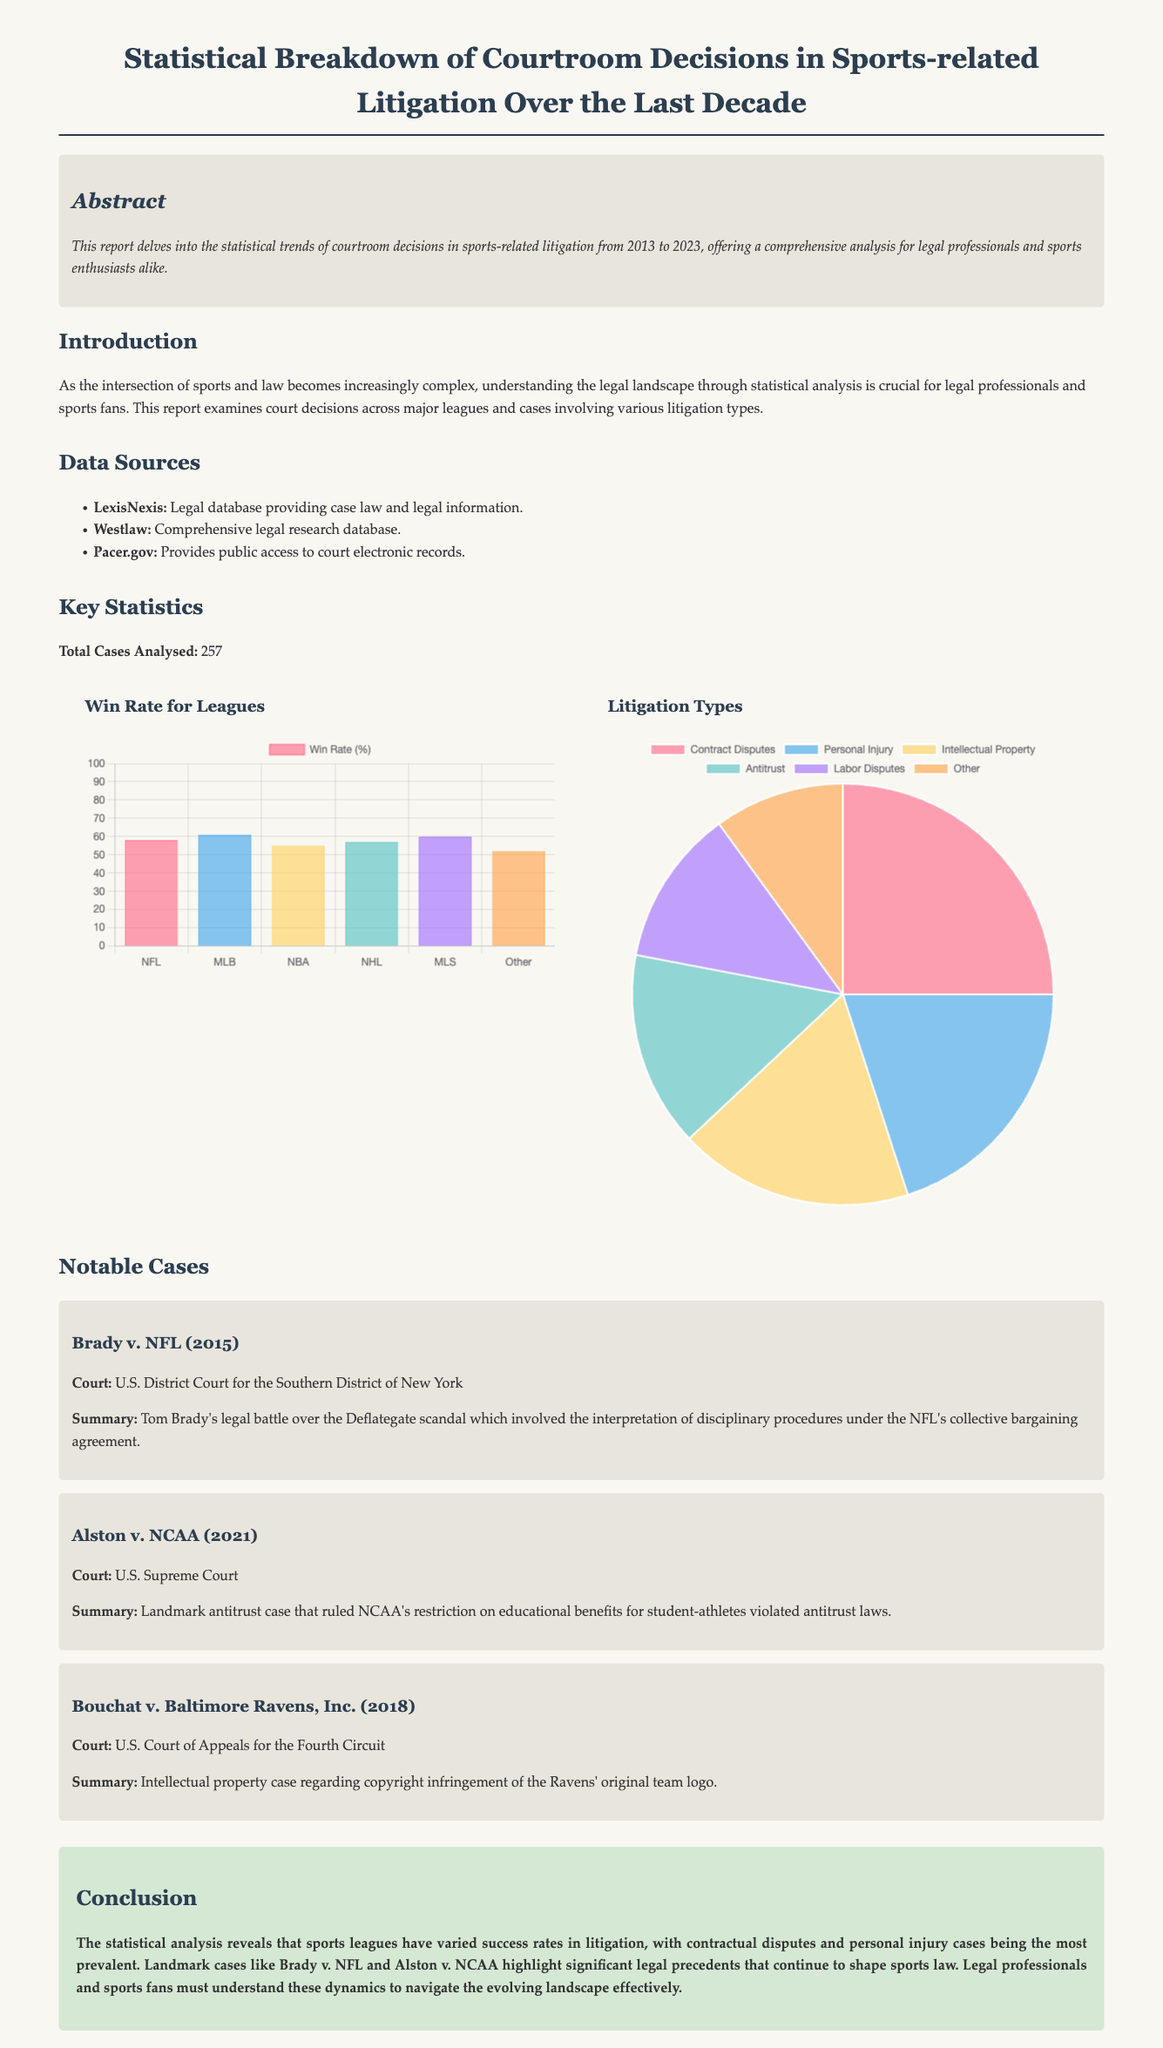what is the total number of cases analyzed? The total number of cases analyzed is stated in the document under "Key Statistics."
Answer: 257 which league has the highest win rate? The league with the highest win rate is indicated in the "Win Rate for Leagues" chart.
Answer: MLB what percentage of cases were related to contract disputes? The percentage of cases related to contract disputes can be found in the "Litigation Types" chart.
Answer: 25 which year did the Alston v. NCAA case occur? The year of the Alston v. NCAA case is mentioned in the "Notable Cases" section.
Answer: 2021 how many types of litigation are listed in the document? The number of litigation types is provided in the "Litigation Types" chart and list.
Answer: 6 what was the main legal issue in Brady v. NFL? The main legal issue in Brady v. NFL is summarized in the "Notable Cases" section.
Answer: Deflategate what court handled the Bouchat v. Baltimore Ravens, Inc. case? The court for Bouchat v. Baltimore Ravens, Inc. is specified in the "Notable Cases" section.
Answer: U.S. Court of Appeals for the Fourth Circuit what is the conclusion of the report focused on? The conclusion addresses the overall findings and implications of the statistical analysis.
Answer: Legal precedents which database is mentioned as a data source for the analysis? The data source is specified in the "Data Sources" section of the report.
Answer: LexisNexis 